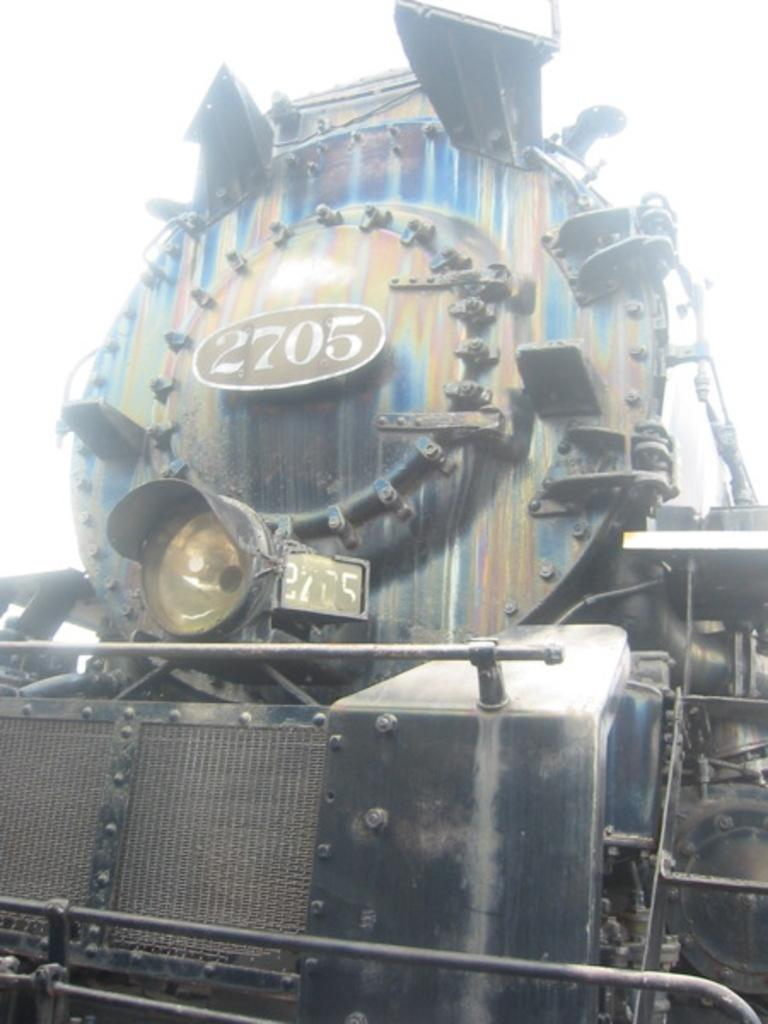What is the main subject of the image? The main subject of the image is a railway engine. What can be seen in the background of the image? The sky is visible in the background of the image. What type of flesh can be seen on the railway engine in the image? There is no flesh present on the railway engine in the image, as it is a mechanical object. 